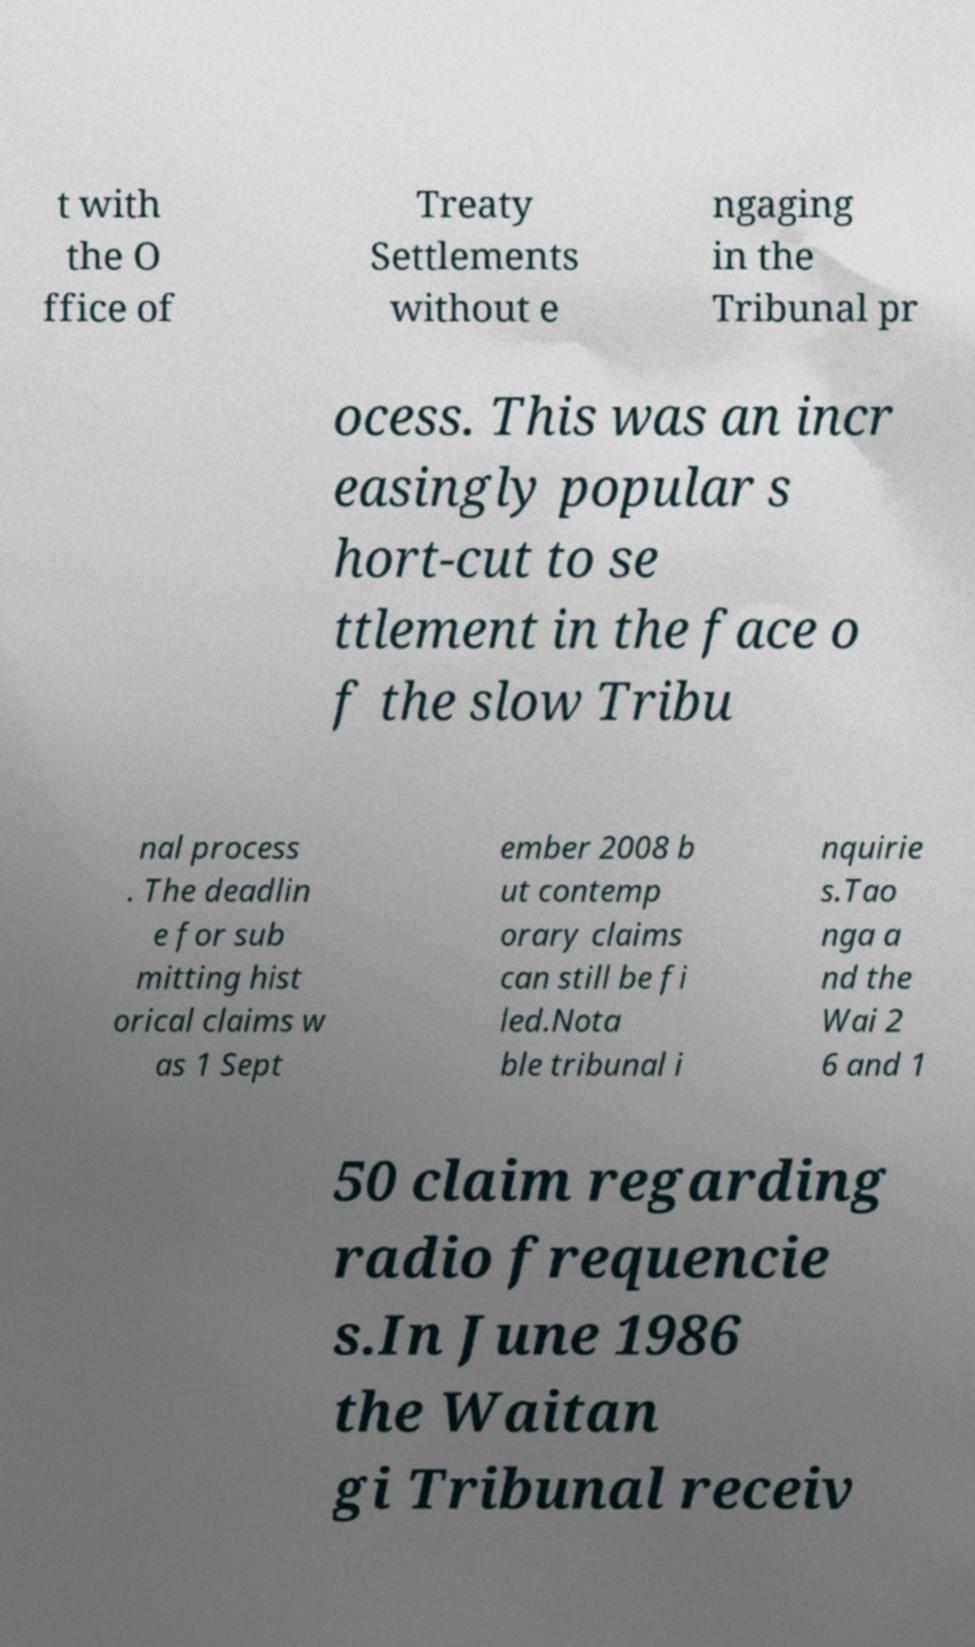I need the written content from this picture converted into text. Can you do that? t with the O ffice of Treaty Settlements without e ngaging in the Tribunal pr ocess. This was an incr easingly popular s hort-cut to se ttlement in the face o f the slow Tribu nal process . The deadlin e for sub mitting hist orical claims w as 1 Sept ember 2008 b ut contemp orary claims can still be fi led.Nota ble tribunal i nquirie s.Tao nga a nd the Wai 2 6 and 1 50 claim regarding radio frequencie s.In June 1986 the Waitan gi Tribunal receiv 